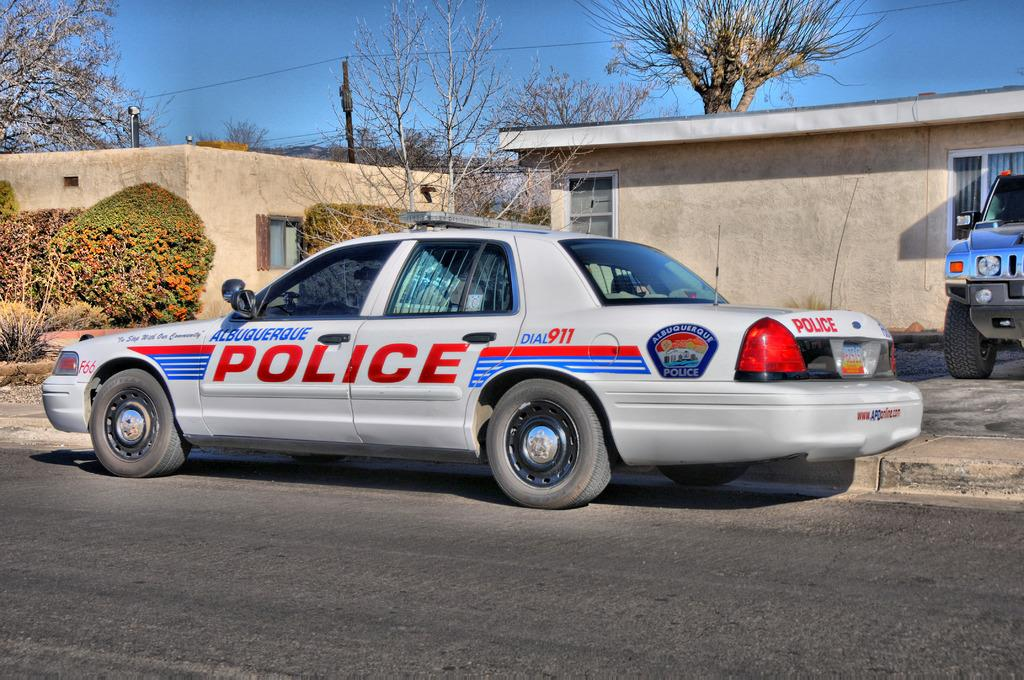Provide a one-sentence caption for the provided image. A Police Car of Albuquerque parked in front of a porch . 